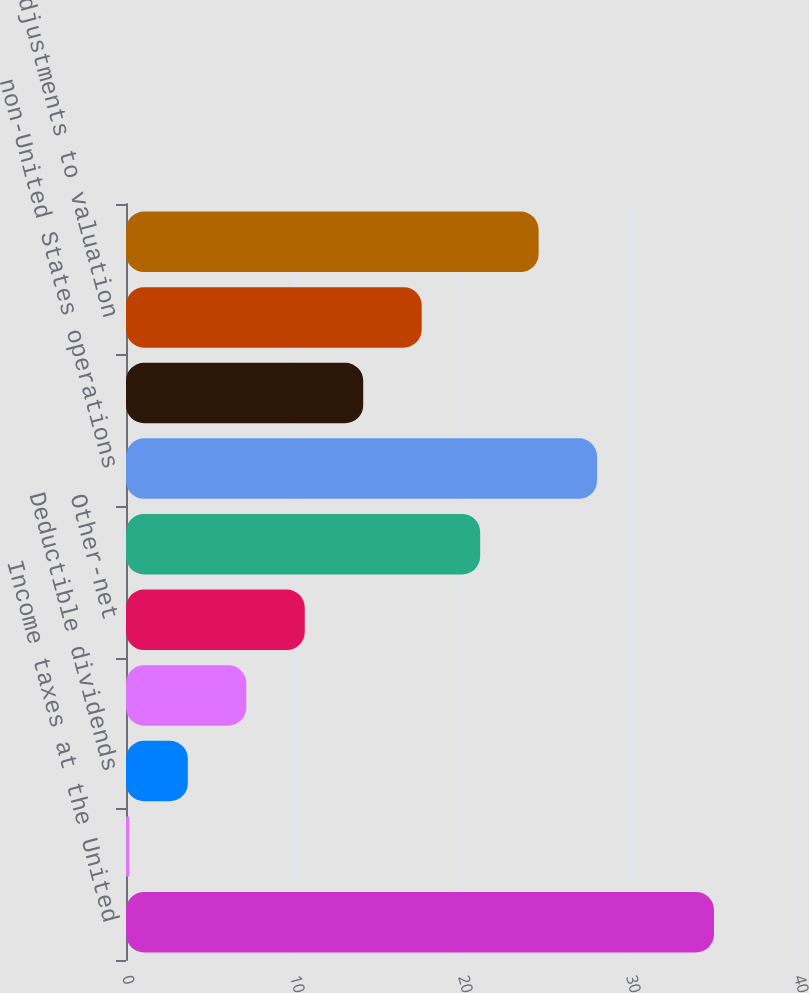Convert chart to OTSL. <chart><loc_0><loc_0><loc_500><loc_500><bar_chart><fcel>Income taxes at the United<fcel>State and local income taxes<fcel>Deductible dividends<fcel>Deductible interest<fcel>Other-net<fcel>United States foreign tax<fcel>non-United States operations<fcel>Adjustments to tax liabilities<fcel>Adjustments to valuation<fcel>Effective income tax expense<nl><fcel>35<fcel>0.2<fcel>3.68<fcel>7.16<fcel>10.64<fcel>21.08<fcel>28.04<fcel>14.12<fcel>17.6<fcel>24.56<nl></chart> 